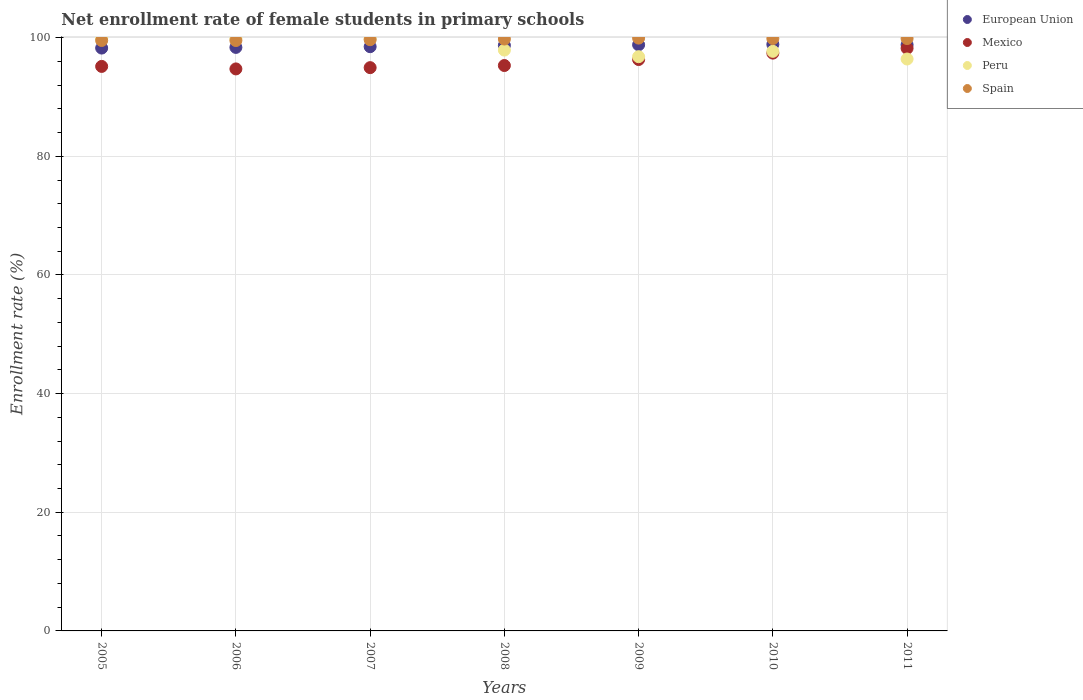What is the net enrollment rate of female students in primary schools in Mexico in 2008?
Provide a short and direct response. 95.3. Across all years, what is the maximum net enrollment rate of female students in primary schools in Mexico?
Ensure brevity in your answer.  98.2. Across all years, what is the minimum net enrollment rate of female students in primary schools in Mexico?
Give a very brief answer. 94.72. In which year was the net enrollment rate of female students in primary schools in Peru maximum?
Provide a short and direct response. 2005. In which year was the net enrollment rate of female students in primary schools in Mexico minimum?
Your answer should be very brief. 2006. What is the total net enrollment rate of female students in primary schools in European Union in the graph?
Offer a very short reply. 690.18. What is the difference between the net enrollment rate of female students in primary schools in Spain in 2008 and that in 2009?
Provide a succinct answer. -0.16. What is the difference between the net enrollment rate of female students in primary schools in Mexico in 2011 and the net enrollment rate of female students in primary schools in Spain in 2010?
Ensure brevity in your answer.  -1.64. What is the average net enrollment rate of female students in primary schools in Peru per year?
Your answer should be compact. 98.33. In the year 2006, what is the difference between the net enrollment rate of female students in primary schools in Spain and net enrollment rate of female students in primary schools in Peru?
Make the answer very short. -0.32. What is the ratio of the net enrollment rate of female students in primary schools in Spain in 2009 to that in 2011?
Keep it short and to the point. 1. Is the difference between the net enrollment rate of female students in primary schools in Spain in 2005 and 2008 greater than the difference between the net enrollment rate of female students in primary schools in Peru in 2005 and 2008?
Your response must be concise. No. What is the difference between the highest and the second highest net enrollment rate of female students in primary schools in Mexico?
Your answer should be very brief. 0.82. What is the difference between the highest and the lowest net enrollment rate of female students in primary schools in Spain?
Ensure brevity in your answer.  0.41. Is the sum of the net enrollment rate of female students in primary schools in European Union in 2008 and 2010 greater than the maximum net enrollment rate of female students in primary schools in Mexico across all years?
Ensure brevity in your answer.  Yes. Is it the case that in every year, the sum of the net enrollment rate of female students in primary schools in Spain and net enrollment rate of female students in primary schools in Mexico  is greater than the sum of net enrollment rate of female students in primary schools in Peru and net enrollment rate of female students in primary schools in European Union?
Ensure brevity in your answer.  No. Is it the case that in every year, the sum of the net enrollment rate of female students in primary schools in Spain and net enrollment rate of female students in primary schools in Mexico  is greater than the net enrollment rate of female students in primary schools in European Union?
Ensure brevity in your answer.  Yes. Does the net enrollment rate of female students in primary schools in Spain monotonically increase over the years?
Your answer should be very brief. No. Is the net enrollment rate of female students in primary schools in Spain strictly greater than the net enrollment rate of female students in primary schools in Peru over the years?
Give a very brief answer. No. How many dotlines are there?
Your response must be concise. 4. What is the difference between two consecutive major ticks on the Y-axis?
Offer a very short reply. 20. Does the graph contain any zero values?
Keep it short and to the point. No. Where does the legend appear in the graph?
Your answer should be compact. Top right. How many legend labels are there?
Your response must be concise. 4. How are the legend labels stacked?
Ensure brevity in your answer.  Vertical. What is the title of the graph?
Provide a succinct answer. Net enrollment rate of female students in primary schools. What is the label or title of the Y-axis?
Make the answer very short. Enrollment rate (%). What is the Enrollment rate (%) of European Union in 2005?
Ensure brevity in your answer.  98.24. What is the Enrollment rate (%) of Mexico in 2005?
Your response must be concise. 95.14. What is the Enrollment rate (%) of Peru in 2005?
Provide a succinct answer. 99.87. What is the Enrollment rate (%) of Spain in 2005?
Give a very brief answer. 99.52. What is the Enrollment rate (%) in European Union in 2006?
Provide a succinct answer. 98.35. What is the Enrollment rate (%) in Mexico in 2006?
Your answer should be compact. 94.72. What is the Enrollment rate (%) in Peru in 2006?
Give a very brief answer. 99.83. What is the Enrollment rate (%) in Spain in 2006?
Provide a succinct answer. 99.51. What is the Enrollment rate (%) in European Union in 2007?
Your answer should be very brief. 98.47. What is the Enrollment rate (%) in Mexico in 2007?
Offer a terse response. 94.94. What is the Enrollment rate (%) of Peru in 2007?
Your answer should be compact. 99.84. What is the Enrollment rate (%) in Spain in 2007?
Your answer should be very brief. 99.65. What is the Enrollment rate (%) in European Union in 2008?
Offer a terse response. 98.69. What is the Enrollment rate (%) in Mexico in 2008?
Your answer should be compact. 95.3. What is the Enrollment rate (%) of Peru in 2008?
Your answer should be very brief. 97.9. What is the Enrollment rate (%) of Spain in 2008?
Your answer should be compact. 99.76. What is the Enrollment rate (%) in European Union in 2009?
Your answer should be compact. 98.79. What is the Enrollment rate (%) of Mexico in 2009?
Provide a short and direct response. 96.31. What is the Enrollment rate (%) in Peru in 2009?
Your answer should be compact. 96.78. What is the Enrollment rate (%) in Spain in 2009?
Keep it short and to the point. 99.91. What is the Enrollment rate (%) in European Union in 2010?
Provide a short and direct response. 98.86. What is the Enrollment rate (%) of Mexico in 2010?
Keep it short and to the point. 97.39. What is the Enrollment rate (%) in Peru in 2010?
Offer a very short reply. 97.69. What is the Enrollment rate (%) in Spain in 2010?
Give a very brief answer. 99.84. What is the Enrollment rate (%) of European Union in 2011?
Offer a terse response. 98.79. What is the Enrollment rate (%) in Mexico in 2011?
Give a very brief answer. 98.2. What is the Enrollment rate (%) of Peru in 2011?
Your answer should be very brief. 96.39. What is the Enrollment rate (%) of Spain in 2011?
Provide a succinct answer. 99.84. Across all years, what is the maximum Enrollment rate (%) of European Union?
Give a very brief answer. 98.86. Across all years, what is the maximum Enrollment rate (%) of Mexico?
Provide a short and direct response. 98.2. Across all years, what is the maximum Enrollment rate (%) of Peru?
Your answer should be compact. 99.87. Across all years, what is the maximum Enrollment rate (%) in Spain?
Keep it short and to the point. 99.91. Across all years, what is the minimum Enrollment rate (%) of European Union?
Your response must be concise. 98.24. Across all years, what is the minimum Enrollment rate (%) in Mexico?
Give a very brief answer. 94.72. Across all years, what is the minimum Enrollment rate (%) of Peru?
Provide a succinct answer. 96.39. Across all years, what is the minimum Enrollment rate (%) in Spain?
Keep it short and to the point. 99.51. What is the total Enrollment rate (%) of European Union in the graph?
Offer a terse response. 690.18. What is the total Enrollment rate (%) of Mexico in the graph?
Provide a short and direct response. 672. What is the total Enrollment rate (%) in Peru in the graph?
Provide a short and direct response. 688.3. What is the total Enrollment rate (%) in Spain in the graph?
Your answer should be very brief. 698.03. What is the difference between the Enrollment rate (%) in European Union in 2005 and that in 2006?
Your answer should be very brief. -0.11. What is the difference between the Enrollment rate (%) in Mexico in 2005 and that in 2006?
Offer a terse response. 0.42. What is the difference between the Enrollment rate (%) of Peru in 2005 and that in 2006?
Make the answer very short. 0.04. What is the difference between the Enrollment rate (%) in Spain in 2005 and that in 2006?
Provide a short and direct response. 0.01. What is the difference between the Enrollment rate (%) in European Union in 2005 and that in 2007?
Keep it short and to the point. -0.23. What is the difference between the Enrollment rate (%) in Mexico in 2005 and that in 2007?
Provide a short and direct response. 0.21. What is the difference between the Enrollment rate (%) of Peru in 2005 and that in 2007?
Provide a succinct answer. 0.03. What is the difference between the Enrollment rate (%) of Spain in 2005 and that in 2007?
Your answer should be compact. -0.13. What is the difference between the Enrollment rate (%) of European Union in 2005 and that in 2008?
Provide a succinct answer. -0.46. What is the difference between the Enrollment rate (%) of Mexico in 2005 and that in 2008?
Provide a short and direct response. -0.15. What is the difference between the Enrollment rate (%) of Peru in 2005 and that in 2008?
Offer a very short reply. 1.97. What is the difference between the Enrollment rate (%) of Spain in 2005 and that in 2008?
Ensure brevity in your answer.  -0.24. What is the difference between the Enrollment rate (%) in European Union in 2005 and that in 2009?
Give a very brief answer. -0.55. What is the difference between the Enrollment rate (%) in Mexico in 2005 and that in 2009?
Keep it short and to the point. -1.16. What is the difference between the Enrollment rate (%) in Peru in 2005 and that in 2009?
Provide a short and direct response. 3.09. What is the difference between the Enrollment rate (%) in Spain in 2005 and that in 2009?
Keep it short and to the point. -0.4. What is the difference between the Enrollment rate (%) in European Union in 2005 and that in 2010?
Your answer should be very brief. -0.62. What is the difference between the Enrollment rate (%) of Mexico in 2005 and that in 2010?
Ensure brevity in your answer.  -2.24. What is the difference between the Enrollment rate (%) in Peru in 2005 and that in 2010?
Make the answer very short. 2.18. What is the difference between the Enrollment rate (%) of Spain in 2005 and that in 2010?
Provide a short and direct response. -0.32. What is the difference between the Enrollment rate (%) in European Union in 2005 and that in 2011?
Ensure brevity in your answer.  -0.55. What is the difference between the Enrollment rate (%) in Mexico in 2005 and that in 2011?
Give a very brief answer. -3.06. What is the difference between the Enrollment rate (%) of Peru in 2005 and that in 2011?
Ensure brevity in your answer.  3.48. What is the difference between the Enrollment rate (%) in Spain in 2005 and that in 2011?
Provide a succinct answer. -0.33. What is the difference between the Enrollment rate (%) of European Union in 2006 and that in 2007?
Give a very brief answer. -0.12. What is the difference between the Enrollment rate (%) of Mexico in 2006 and that in 2007?
Provide a short and direct response. -0.21. What is the difference between the Enrollment rate (%) of Peru in 2006 and that in 2007?
Make the answer very short. -0.01. What is the difference between the Enrollment rate (%) of Spain in 2006 and that in 2007?
Keep it short and to the point. -0.14. What is the difference between the Enrollment rate (%) in European Union in 2006 and that in 2008?
Offer a terse response. -0.35. What is the difference between the Enrollment rate (%) of Mexico in 2006 and that in 2008?
Offer a terse response. -0.57. What is the difference between the Enrollment rate (%) of Peru in 2006 and that in 2008?
Your answer should be compact. 1.93. What is the difference between the Enrollment rate (%) of Spain in 2006 and that in 2008?
Your answer should be compact. -0.25. What is the difference between the Enrollment rate (%) in European Union in 2006 and that in 2009?
Provide a short and direct response. -0.44. What is the difference between the Enrollment rate (%) in Mexico in 2006 and that in 2009?
Your answer should be very brief. -1.58. What is the difference between the Enrollment rate (%) of Peru in 2006 and that in 2009?
Keep it short and to the point. 3.05. What is the difference between the Enrollment rate (%) of Spain in 2006 and that in 2009?
Provide a succinct answer. -0.41. What is the difference between the Enrollment rate (%) of European Union in 2006 and that in 2010?
Give a very brief answer. -0.51. What is the difference between the Enrollment rate (%) of Mexico in 2006 and that in 2010?
Your answer should be compact. -2.66. What is the difference between the Enrollment rate (%) of Peru in 2006 and that in 2010?
Offer a terse response. 2.14. What is the difference between the Enrollment rate (%) of Spain in 2006 and that in 2010?
Offer a terse response. -0.33. What is the difference between the Enrollment rate (%) of European Union in 2006 and that in 2011?
Offer a terse response. -0.44. What is the difference between the Enrollment rate (%) of Mexico in 2006 and that in 2011?
Your response must be concise. -3.48. What is the difference between the Enrollment rate (%) of Peru in 2006 and that in 2011?
Your response must be concise. 3.44. What is the difference between the Enrollment rate (%) in Spain in 2006 and that in 2011?
Make the answer very short. -0.34. What is the difference between the Enrollment rate (%) of European Union in 2007 and that in 2008?
Your answer should be very brief. -0.22. What is the difference between the Enrollment rate (%) of Mexico in 2007 and that in 2008?
Provide a succinct answer. -0.36. What is the difference between the Enrollment rate (%) of Peru in 2007 and that in 2008?
Ensure brevity in your answer.  1.95. What is the difference between the Enrollment rate (%) in Spain in 2007 and that in 2008?
Give a very brief answer. -0.11. What is the difference between the Enrollment rate (%) in European Union in 2007 and that in 2009?
Provide a short and direct response. -0.32. What is the difference between the Enrollment rate (%) in Mexico in 2007 and that in 2009?
Your answer should be compact. -1.37. What is the difference between the Enrollment rate (%) in Peru in 2007 and that in 2009?
Your response must be concise. 3.06. What is the difference between the Enrollment rate (%) of Spain in 2007 and that in 2009?
Offer a very short reply. -0.27. What is the difference between the Enrollment rate (%) of European Union in 2007 and that in 2010?
Give a very brief answer. -0.39. What is the difference between the Enrollment rate (%) of Mexico in 2007 and that in 2010?
Make the answer very short. -2.45. What is the difference between the Enrollment rate (%) of Peru in 2007 and that in 2010?
Your answer should be compact. 2.16. What is the difference between the Enrollment rate (%) in Spain in 2007 and that in 2010?
Provide a succinct answer. -0.19. What is the difference between the Enrollment rate (%) of European Union in 2007 and that in 2011?
Provide a succinct answer. -0.32. What is the difference between the Enrollment rate (%) of Mexico in 2007 and that in 2011?
Make the answer very short. -3.26. What is the difference between the Enrollment rate (%) in Peru in 2007 and that in 2011?
Offer a very short reply. 3.45. What is the difference between the Enrollment rate (%) in Spain in 2007 and that in 2011?
Your answer should be compact. -0.2. What is the difference between the Enrollment rate (%) of European Union in 2008 and that in 2009?
Give a very brief answer. -0.09. What is the difference between the Enrollment rate (%) of Mexico in 2008 and that in 2009?
Your answer should be very brief. -1.01. What is the difference between the Enrollment rate (%) in Peru in 2008 and that in 2009?
Offer a very short reply. 1.11. What is the difference between the Enrollment rate (%) in Spain in 2008 and that in 2009?
Keep it short and to the point. -0.16. What is the difference between the Enrollment rate (%) of European Union in 2008 and that in 2010?
Ensure brevity in your answer.  -0.16. What is the difference between the Enrollment rate (%) of Mexico in 2008 and that in 2010?
Provide a short and direct response. -2.09. What is the difference between the Enrollment rate (%) of Peru in 2008 and that in 2010?
Provide a succinct answer. 0.21. What is the difference between the Enrollment rate (%) in Spain in 2008 and that in 2010?
Offer a terse response. -0.08. What is the difference between the Enrollment rate (%) of European Union in 2008 and that in 2011?
Offer a terse response. -0.09. What is the difference between the Enrollment rate (%) in Mexico in 2008 and that in 2011?
Ensure brevity in your answer.  -2.91. What is the difference between the Enrollment rate (%) in Peru in 2008 and that in 2011?
Offer a very short reply. 1.5. What is the difference between the Enrollment rate (%) of Spain in 2008 and that in 2011?
Your answer should be compact. -0.09. What is the difference between the Enrollment rate (%) of European Union in 2009 and that in 2010?
Your answer should be compact. -0.07. What is the difference between the Enrollment rate (%) in Mexico in 2009 and that in 2010?
Give a very brief answer. -1.08. What is the difference between the Enrollment rate (%) of Peru in 2009 and that in 2010?
Provide a short and direct response. -0.9. What is the difference between the Enrollment rate (%) of Spain in 2009 and that in 2010?
Provide a short and direct response. 0.07. What is the difference between the Enrollment rate (%) in European Union in 2009 and that in 2011?
Provide a short and direct response. 0. What is the difference between the Enrollment rate (%) of Mexico in 2009 and that in 2011?
Offer a very short reply. -1.9. What is the difference between the Enrollment rate (%) in Peru in 2009 and that in 2011?
Offer a terse response. 0.39. What is the difference between the Enrollment rate (%) in Spain in 2009 and that in 2011?
Keep it short and to the point. 0.07. What is the difference between the Enrollment rate (%) of European Union in 2010 and that in 2011?
Your answer should be very brief. 0.07. What is the difference between the Enrollment rate (%) of Mexico in 2010 and that in 2011?
Offer a very short reply. -0.82. What is the difference between the Enrollment rate (%) of Peru in 2010 and that in 2011?
Give a very brief answer. 1.29. What is the difference between the Enrollment rate (%) in Spain in 2010 and that in 2011?
Keep it short and to the point. -0. What is the difference between the Enrollment rate (%) in European Union in 2005 and the Enrollment rate (%) in Mexico in 2006?
Your answer should be very brief. 3.51. What is the difference between the Enrollment rate (%) of European Union in 2005 and the Enrollment rate (%) of Peru in 2006?
Offer a very short reply. -1.59. What is the difference between the Enrollment rate (%) in European Union in 2005 and the Enrollment rate (%) in Spain in 2006?
Give a very brief answer. -1.27. What is the difference between the Enrollment rate (%) of Mexico in 2005 and the Enrollment rate (%) of Peru in 2006?
Offer a very short reply. -4.69. What is the difference between the Enrollment rate (%) of Mexico in 2005 and the Enrollment rate (%) of Spain in 2006?
Give a very brief answer. -4.36. What is the difference between the Enrollment rate (%) in Peru in 2005 and the Enrollment rate (%) in Spain in 2006?
Keep it short and to the point. 0.36. What is the difference between the Enrollment rate (%) of European Union in 2005 and the Enrollment rate (%) of Mexico in 2007?
Your answer should be compact. 3.3. What is the difference between the Enrollment rate (%) in European Union in 2005 and the Enrollment rate (%) in Peru in 2007?
Offer a terse response. -1.61. What is the difference between the Enrollment rate (%) in European Union in 2005 and the Enrollment rate (%) in Spain in 2007?
Provide a short and direct response. -1.41. What is the difference between the Enrollment rate (%) in Mexico in 2005 and the Enrollment rate (%) in Peru in 2007?
Your answer should be very brief. -4.7. What is the difference between the Enrollment rate (%) in Mexico in 2005 and the Enrollment rate (%) in Spain in 2007?
Give a very brief answer. -4.5. What is the difference between the Enrollment rate (%) of Peru in 2005 and the Enrollment rate (%) of Spain in 2007?
Keep it short and to the point. 0.22. What is the difference between the Enrollment rate (%) of European Union in 2005 and the Enrollment rate (%) of Mexico in 2008?
Provide a short and direct response. 2.94. What is the difference between the Enrollment rate (%) in European Union in 2005 and the Enrollment rate (%) in Peru in 2008?
Ensure brevity in your answer.  0.34. What is the difference between the Enrollment rate (%) of European Union in 2005 and the Enrollment rate (%) of Spain in 2008?
Keep it short and to the point. -1.52. What is the difference between the Enrollment rate (%) in Mexico in 2005 and the Enrollment rate (%) in Peru in 2008?
Keep it short and to the point. -2.75. What is the difference between the Enrollment rate (%) in Mexico in 2005 and the Enrollment rate (%) in Spain in 2008?
Ensure brevity in your answer.  -4.61. What is the difference between the Enrollment rate (%) in Peru in 2005 and the Enrollment rate (%) in Spain in 2008?
Give a very brief answer. 0.11. What is the difference between the Enrollment rate (%) in European Union in 2005 and the Enrollment rate (%) in Mexico in 2009?
Give a very brief answer. 1.93. What is the difference between the Enrollment rate (%) in European Union in 2005 and the Enrollment rate (%) in Peru in 2009?
Make the answer very short. 1.45. What is the difference between the Enrollment rate (%) of European Union in 2005 and the Enrollment rate (%) of Spain in 2009?
Offer a very short reply. -1.68. What is the difference between the Enrollment rate (%) of Mexico in 2005 and the Enrollment rate (%) of Peru in 2009?
Your answer should be compact. -1.64. What is the difference between the Enrollment rate (%) of Mexico in 2005 and the Enrollment rate (%) of Spain in 2009?
Make the answer very short. -4.77. What is the difference between the Enrollment rate (%) of Peru in 2005 and the Enrollment rate (%) of Spain in 2009?
Your answer should be compact. -0.05. What is the difference between the Enrollment rate (%) in European Union in 2005 and the Enrollment rate (%) in Mexico in 2010?
Keep it short and to the point. 0.85. What is the difference between the Enrollment rate (%) of European Union in 2005 and the Enrollment rate (%) of Peru in 2010?
Your answer should be compact. 0.55. What is the difference between the Enrollment rate (%) in European Union in 2005 and the Enrollment rate (%) in Spain in 2010?
Your response must be concise. -1.6. What is the difference between the Enrollment rate (%) in Mexico in 2005 and the Enrollment rate (%) in Peru in 2010?
Your response must be concise. -2.54. What is the difference between the Enrollment rate (%) of Mexico in 2005 and the Enrollment rate (%) of Spain in 2010?
Your answer should be compact. -4.7. What is the difference between the Enrollment rate (%) of Peru in 2005 and the Enrollment rate (%) of Spain in 2010?
Your answer should be very brief. 0.03. What is the difference between the Enrollment rate (%) of European Union in 2005 and the Enrollment rate (%) of Mexico in 2011?
Keep it short and to the point. 0.03. What is the difference between the Enrollment rate (%) in European Union in 2005 and the Enrollment rate (%) in Peru in 2011?
Offer a very short reply. 1.84. What is the difference between the Enrollment rate (%) of European Union in 2005 and the Enrollment rate (%) of Spain in 2011?
Make the answer very short. -1.61. What is the difference between the Enrollment rate (%) of Mexico in 2005 and the Enrollment rate (%) of Peru in 2011?
Ensure brevity in your answer.  -1.25. What is the difference between the Enrollment rate (%) in Mexico in 2005 and the Enrollment rate (%) in Spain in 2011?
Ensure brevity in your answer.  -4.7. What is the difference between the Enrollment rate (%) in Peru in 2005 and the Enrollment rate (%) in Spain in 2011?
Provide a short and direct response. 0.03. What is the difference between the Enrollment rate (%) in European Union in 2006 and the Enrollment rate (%) in Mexico in 2007?
Your response must be concise. 3.41. What is the difference between the Enrollment rate (%) of European Union in 2006 and the Enrollment rate (%) of Peru in 2007?
Provide a succinct answer. -1.5. What is the difference between the Enrollment rate (%) in European Union in 2006 and the Enrollment rate (%) in Spain in 2007?
Offer a very short reply. -1.3. What is the difference between the Enrollment rate (%) of Mexico in 2006 and the Enrollment rate (%) of Peru in 2007?
Give a very brief answer. -5.12. What is the difference between the Enrollment rate (%) in Mexico in 2006 and the Enrollment rate (%) in Spain in 2007?
Offer a terse response. -4.92. What is the difference between the Enrollment rate (%) in Peru in 2006 and the Enrollment rate (%) in Spain in 2007?
Provide a succinct answer. 0.18. What is the difference between the Enrollment rate (%) in European Union in 2006 and the Enrollment rate (%) in Mexico in 2008?
Offer a very short reply. 3.05. What is the difference between the Enrollment rate (%) in European Union in 2006 and the Enrollment rate (%) in Peru in 2008?
Keep it short and to the point. 0.45. What is the difference between the Enrollment rate (%) of European Union in 2006 and the Enrollment rate (%) of Spain in 2008?
Offer a very short reply. -1.41. What is the difference between the Enrollment rate (%) in Mexico in 2006 and the Enrollment rate (%) in Peru in 2008?
Make the answer very short. -3.17. What is the difference between the Enrollment rate (%) in Mexico in 2006 and the Enrollment rate (%) in Spain in 2008?
Give a very brief answer. -5.03. What is the difference between the Enrollment rate (%) of Peru in 2006 and the Enrollment rate (%) of Spain in 2008?
Offer a terse response. 0.07. What is the difference between the Enrollment rate (%) in European Union in 2006 and the Enrollment rate (%) in Mexico in 2009?
Your answer should be very brief. 2.04. What is the difference between the Enrollment rate (%) of European Union in 2006 and the Enrollment rate (%) of Peru in 2009?
Make the answer very short. 1.57. What is the difference between the Enrollment rate (%) of European Union in 2006 and the Enrollment rate (%) of Spain in 2009?
Provide a short and direct response. -1.57. What is the difference between the Enrollment rate (%) of Mexico in 2006 and the Enrollment rate (%) of Peru in 2009?
Your answer should be very brief. -2.06. What is the difference between the Enrollment rate (%) in Mexico in 2006 and the Enrollment rate (%) in Spain in 2009?
Your answer should be compact. -5.19. What is the difference between the Enrollment rate (%) in Peru in 2006 and the Enrollment rate (%) in Spain in 2009?
Your answer should be compact. -0.08. What is the difference between the Enrollment rate (%) of European Union in 2006 and the Enrollment rate (%) of Mexico in 2010?
Your answer should be very brief. 0.96. What is the difference between the Enrollment rate (%) in European Union in 2006 and the Enrollment rate (%) in Peru in 2010?
Offer a terse response. 0.66. What is the difference between the Enrollment rate (%) in European Union in 2006 and the Enrollment rate (%) in Spain in 2010?
Your answer should be very brief. -1.49. What is the difference between the Enrollment rate (%) in Mexico in 2006 and the Enrollment rate (%) in Peru in 2010?
Make the answer very short. -2.96. What is the difference between the Enrollment rate (%) of Mexico in 2006 and the Enrollment rate (%) of Spain in 2010?
Your response must be concise. -5.12. What is the difference between the Enrollment rate (%) of Peru in 2006 and the Enrollment rate (%) of Spain in 2010?
Your answer should be compact. -0.01. What is the difference between the Enrollment rate (%) of European Union in 2006 and the Enrollment rate (%) of Mexico in 2011?
Ensure brevity in your answer.  0.15. What is the difference between the Enrollment rate (%) in European Union in 2006 and the Enrollment rate (%) in Peru in 2011?
Provide a succinct answer. 1.96. What is the difference between the Enrollment rate (%) in European Union in 2006 and the Enrollment rate (%) in Spain in 2011?
Offer a terse response. -1.49. What is the difference between the Enrollment rate (%) of Mexico in 2006 and the Enrollment rate (%) of Peru in 2011?
Offer a very short reply. -1.67. What is the difference between the Enrollment rate (%) in Mexico in 2006 and the Enrollment rate (%) in Spain in 2011?
Offer a terse response. -5.12. What is the difference between the Enrollment rate (%) of Peru in 2006 and the Enrollment rate (%) of Spain in 2011?
Offer a terse response. -0.01. What is the difference between the Enrollment rate (%) in European Union in 2007 and the Enrollment rate (%) in Mexico in 2008?
Your answer should be very brief. 3.18. What is the difference between the Enrollment rate (%) of European Union in 2007 and the Enrollment rate (%) of Peru in 2008?
Make the answer very short. 0.57. What is the difference between the Enrollment rate (%) of European Union in 2007 and the Enrollment rate (%) of Spain in 2008?
Give a very brief answer. -1.29. What is the difference between the Enrollment rate (%) in Mexico in 2007 and the Enrollment rate (%) in Peru in 2008?
Your response must be concise. -2.96. What is the difference between the Enrollment rate (%) of Mexico in 2007 and the Enrollment rate (%) of Spain in 2008?
Your answer should be very brief. -4.82. What is the difference between the Enrollment rate (%) of Peru in 2007 and the Enrollment rate (%) of Spain in 2008?
Provide a succinct answer. 0.09. What is the difference between the Enrollment rate (%) of European Union in 2007 and the Enrollment rate (%) of Mexico in 2009?
Make the answer very short. 2.16. What is the difference between the Enrollment rate (%) of European Union in 2007 and the Enrollment rate (%) of Peru in 2009?
Provide a short and direct response. 1.69. What is the difference between the Enrollment rate (%) of European Union in 2007 and the Enrollment rate (%) of Spain in 2009?
Make the answer very short. -1.44. What is the difference between the Enrollment rate (%) in Mexico in 2007 and the Enrollment rate (%) in Peru in 2009?
Give a very brief answer. -1.84. What is the difference between the Enrollment rate (%) in Mexico in 2007 and the Enrollment rate (%) in Spain in 2009?
Offer a terse response. -4.98. What is the difference between the Enrollment rate (%) of Peru in 2007 and the Enrollment rate (%) of Spain in 2009?
Provide a short and direct response. -0.07. What is the difference between the Enrollment rate (%) of European Union in 2007 and the Enrollment rate (%) of Mexico in 2010?
Your answer should be very brief. 1.09. What is the difference between the Enrollment rate (%) of European Union in 2007 and the Enrollment rate (%) of Peru in 2010?
Ensure brevity in your answer.  0.78. What is the difference between the Enrollment rate (%) in European Union in 2007 and the Enrollment rate (%) in Spain in 2010?
Offer a terse response. -1.37. What is the difference between the Enrollment rate (%) in Mexico in 2007 and the Enrollment rate (%) in Peru in 2010?
Offer a terse response. -2.75. What is the difference between the Enrollment rate (%) of Mexico in 2007 and the Enrollment rate (%) of Spain in 2010?
Give a very brief answer. -4.9. What is the difference between the Enrollment rate (%) of Peru in 2007 and the Enrollment rate (%) of Spain in 2010?
Your answer should be compact. 0. What is the difference between the Enrollment rate (%) in European Union in 2007 and the Enrollment rate (%) in Mexico in 2011?
Give a very brief answer. 0.27. What is the difference between the Enrollment rate (%) of European Union in 2007 and the Enrollment rate (%) of Peru in 2011?
Give a very brief answer. 2.08. What is the difference between the Enrollment rate (%) of European Union in 2007 and the Enrollment rate (%) of Spain in 2011?
Provide a succinct answer. -1.37. What is the difference between the Enrollment rate (%) of Mexico in 2007 and the Enrollment rate (%) of Peru in 2011?
Give a very brief answer. -1.45. What is the difference between the Enrollment rate (%) of Mexico in 2007 and the Enrollment rate (%) of Spain in 2011?
Give a very brief answer. -4.91. What is the difference between the Enrollment rate (%) of Peru in 2007 and the Enrollment rate (%) of Spain in 2011?
Give a very brief answer. 0. What is the difference between the Enrollment rate (%) in European Union in 2008 and the Enrollment rate (%) in Mexico in 2009?
Provide a short and direct response. 2.39. What is the difference between the Enrollment rate (%) of European Union in 2008 and the Enrollment rate (%) of Peru in 2009?
Make the answer very short. 1.91. What is the difference between the Enrollment rate (%) in European Union in 2008 and the Enrollment rate (%) in Spain in 2009?
Keep it short and to the point. -1.22. What is the difference between the Enrollment rate (%) in Mexico in 2008 and the Enrollment rate (%) in Peru in 2009?
Keep it short and to the point. -1.49. What is the difference between the Enrollment rate (%) of Mexico in 2008 and the Enrollment rate (%) of Spain in 2009?
Give a very brief answer. -4.62. What is the difference between the Enrollment rate (%) in Peru in 2008 and the Enrollment rate (%) in Spain in 2009?
Keep it short and to the point. -2.02. What is the difference between the Enrollment rate (%) of European Union in 2008 and the Enrollment rate (%) of Mexico in 2010?
Your response must be concise. 1.31. What is the difference between the Enrollment rate (%) in European Union in 2008 and the Enrollment rate (%) in Peru in 2010?
Ensure brevity in your answer.  1.01. What is the difference between the Enrollment rate (%) in European Union in 2008 and the Enrollment rate (%) in Spain in 2010?
Provide a succinct answer. -1.15. What is the difference between the Enrollment rate (%) of Mexico in 2008 and the Enrollment rate (%) of Peru in 2010?
Make the answer very short. -2.39. What is the difference between the Enrollment rate (%) in Mexico in 2008 and the Enrollment rate (%) in Spain in 2010?
Ensure brevity in your answer.  -4.54. What is the difference between the Enrollment rate (%) of Peru in 2008 and the Enrollment rate (%) of Spain in 2010?
Your answer should be compact. -1.94. What is the difference between the Enrollment rate (%) in European Union in 2008 and the Enrollment rate (%) in Mexico in 2011?
Offer a very short reply. 0.49. What is the difference between the Enrollment rate (%) in European Union in 2008 and the Enrollment rate (%) in Peru in 2011?
Make the answer very short. 2.3. What is the difference between the Enrollment rate (%) in European Union in 2008 and the Enrollment rate (%) in Spain in 2011?
Offer a very short reply. -1.15. What is the difference between the Enrollment rate (%) in Mexico in 2008 and the Enrollment rate (%) in Peru in 2011?
Your response must be concise. -1.1. What is the difference between the Enrollment rate (%) of Mexico in 2008 and the Enrollment rate (%) of Spain in 2011?
Keep it short and to the point. -4.55. What is the difference between the Enrollment rate (%) of Peru in 2008 and the Enrollment rate (%) of Spain in 2011?
Your response must be concise. -1.95. What is the difference between the Enrollment rate (%) in European Union in 2009 and the Enrollment rate (%) in Mexico in 2010?
Give a very brief answer. 1.4. What is the difference between the Enrollment rate (%) in European Union in 2009 and the Enrollment rate (%) in Peru in 2010?
Your response must be concise. 1.1. What is the difference between the Enrollment rate (%) in European Union in 2009 and the Enrollment rate (%) in Spain in 2010?
Offer a very short reply. -1.05. What is the difference between the Enrollment rate (%) in Mexico in 2009 and the Enrollment rate (%) in Peru in 2010?
Provide a succinct answer. -1.38. What is the difference between the Enrollment rate (%) in Mexico in 2009 and the Enrollment rate (%) in Spain in 2010?
Provide a short and direct response. -3.53. What is the difference between the Enrollment rate (%) of Peru in 2009 and the Enrollment rate (%) of Spain in 2010?
Offer a terse response. -3.06. What is the difference between the Enrollment rate (%) in European Union in 2009 and the Enrollment rate (%) in Mexico in 2011?
Provide a short and direct response. 0.58. What is the difference between the Enrollment rate (%) in European Union in 2009 and the Enrollment rate (%) in Peru in 2011?
Your response must be concise. 2.39. What is the difference between the Enrollment rate (%) in European Union in 2009 and the Enrollment rate (%) in Spain in 2011?
Ensure brevity in your answer.  -1.06. What is the difference between the Enrollment rate (%) of Mexico in 2009 and the Enrollment rate (%) of Peru in 2011?
Make the answer very short. -0.09. What is the difference between the Enrollment rate (%) of Mexico in 2009 and the Enrollment rate (%) of Spain in 2011?
Provide a succinct answer. -3.54. What is the difference between the Enrollment rate (%) in Peru in 2009 and the Enrollment rate (%) in Spain in 2011?
Provide a short and direct response. -3.06. What is the difference between the Enrollment rate (%) of European Union in 2010 and the Enrollment rate (%) of Mexico in 2011?
Your response must be concise. 0.65. What is the difference between the Enrollment rate (%) in European Union in 2010 and the Enrollment rate (%) in Peru in 2011?
Give a very brief answer. 2.46. What is the difference between the Enrollment rate (%) in European Union in 2010 and the Enrollment rate (%) in Spain in 2011?
Provide a succinct answer. -0.99. What is the difference between the Enrollment rate (%) in Mexico in 2010 and the Enrollment rate (%) in Peru in 2011?
Your answer should be very brief. 0.99. What is the difference between the Enrollment rate (%) of Mexico in 2010 and the Enrollment rate (%) of Spain in 2011?
Provide a succinct answer. -2.46. What is the difference between the Enrollment rate (%) in Peru in 2010 and the Enrollment rate (%) in Spain in 2011?
Offer a terse response. -2.16. What is the average Enrollment rate (%) of European Union per year?
Provide a succinct answer. 98.6. What is the average Enrollment rate (%) of Mexico per year?
Offer a very short reply. 96. What is the average Enrollment rate (%) in Peru per year?
Provide a short and direct response. 98.33. What is the average Enrollment rate (%) of Spain per year?
Provide a succinct answer. 99.72. In the year 2005, what is the difference between the Enrollment rate (%) of European Union and Enrollment rate (%) of Mexico?
Offer a terse response. 3.09. In the year 2005, what is the difference between the Enrollment rate (%) of European Union and Enrollment rate (%) of Peru?
Keep it short and to the point. -1.63. In the year 2005, what is the difference between the Enrollment rate (%) in European Union and Enrollment rate (%) in Spain?
Offer a very short reply. -1.28. In the year 2005, what is the difference between the Enrollment rate (%) in Mexico and Enrollment rate (%) in Peru?
Offer a terse response. -4.73. In the year 2005, what is the difference between the Enrollment rate (%) of Mexico and Enrollment rate (%) of Spain?
Provide a succinct answer. -4.37. In the year 2005, what is the difference between the Enrollment rate (%) of Peru and Enrollment rate (%) of Spain?
Your answer should be compact. 0.35. In the year 2006, what is the difference between the Enrollment rate (%) in European Union and Enrollment rate (%) in Mexico?
Ensure brevity in your answer.  3.63. In the year 2006, what is the difference between the Enrollment rate (%) in European Union and Enrollment rate (%) in Peru?
Give a very brief answer. -1.48. In the year 2006, what is the difference between the Enrollment rate (%) in European Union and Enrollment rate (%) in Spain?
Your response must be concise. -1.16. In the year 2006, what is the difference between the Enrollment rate (%) of Mexico and Enrollment rate (%) of Peru?
Your response must be concise. -5.11. In the year 2006, what is the difference between the Enrollment rate (%) of Mexico and Enrollment rate (%) of Spain?
Offer a very short reply. -4.78. In the year 2006, what is the difference between the Enrollment rate (%) of Peru and Enrollment rate (%) of Spain?
Provide a short and direct response. 0.32. In the year 2007, what is the difference between the Enrollment rate (%) of European Union and Enrollment rate (%) of Mexico?
Your response must be concise. 3.53. In the year 2007, what is the difference between the Enrollment rate (%) in European Union and Enrollment rate (%) in Peru?
Your answer should be compact. -1.37. In the year 2007, what is the difference between the Enrollment rate (%) of European Union and Enrollment rate (%) of Spain?
Provide a succinct answer. -1.18. In the year 2007, what is the difference between the Enrollment rate (%) of Mexico and Enrollment rate (%) of Peru?
Provide a succinct answer. -4.91. In the year 2007, what is the difference between the Enrollment rate (%) of Mexico and Enrollment rate (%) of Spain?
Provide a short and direct response. -4.71. In the year 2007, what is the difference between the Enrollment rate (%) of Peru and Enrollment rate (%) of Spain?
Provide a short and direct response. 0.2. In the year 2008, what is the difference between the Enrollment rate (%) in European Union and Enrollment rate (%) in Mexico?
Offer a terse response. 3.4. In the year 2008, what is the difference between the Enrollment rate (%) in European Union and Enrollment rate (%) in Peru?
Give a very brief answer. 0.8. In the year 2008, what is the difference between the Enrollment rate (%) in European Union and Enrollment rate (%) in Spain?
Provide a succinct answer. -1.06. In the year 2008, what is the difference between the Enrollment rate (%) in Mexico and Enrollment rate (%) in Peru?
Give a very brief answer. -2.6. In the year 2008, what is the difference between the Enrollment rate (%) in Mexico and Enrollment rate (%) in Spain?
Ensure brevity in your answer.  -4.46. In the year 2008, what is the difference between the Enrollment rate (%) in Peru and Enrollment rate (%) in Spain?
Your answer should be very brief. -1.86. In the year 2009, what is the difference between the Enrollment rate (%) in European Union and Enrollment rate (%) in Mexico?
Your answer should be very brief. 2.48. In the year 2009, what is the difference between the Enrollment rate (%) in European Union and Enrollment rate (%) in Peru?
Make the answer very short. 2. In the year 2009, what is the difference between the Enrollment rate (%) of European Union and Enrollment rate (%) of Spain?
Give a very brief answer. -1.13. In the year 2009, what is the difference between the Enrollment rate (%) in Mexico and Enrollment rate (%) in Peru?
Your response must be concise. -0.48. In the year 2009, what is the difference between the Enrollment rate (%) of Mexico and Enrollment rate (%) of Spain?
Provide a short and direct response. -3.61. In the year 2009, what is the difference between the Enrollment rate (%) of Peru and Enrollment rate (%) of Spain?
Make the answer very short. -3.13. In the year 2010, what is the difference between the Enrollment rate (%) of European Union and Enrollment rate (%) of Mexico?
Keep it short and to the point. 1.47. In the year 2010, what is the difference between the Enrollment rate (%) in European Union and Enrollment rate (%) in Peru?
Provide a succinct answer. 1.17. In the year 2010, what is the difference between the Enrollment rate (%) of European Union and Enrollment rate (%) of Spain?
Your answer should be very brief. -0.98. In the year 2010, what is the difference between the Enrollment rate (%) in Mexico and Enrollment rate (%) in Peru?
Your answer should be compact. -0.3. In the year 2010, what is the difference between the Enrollment rate (%) in Mexico and Enrollment rate (%) in Spain?
Keep it short and to the point. -2.45. In the year 2010, what is the difference between the Enrollment rate (%) of Peru and Enrollment rate (%) of Spain?
Your answer should be compact. -2.15. In the year 2011, what is the difference between the Enrollment rate (%) in European Union and Enrollment rate (%) in Mexico?
Make the answer very short. 0.58. In the year 2011, what is the difference between the Enrollment rate (%) of European Union and Enrollment rate (%) of Peru?
Make the answer very short. 2.39. In the year 2011, what is the difference between the Enrollment rate (%) of European Union and Enrollment rate (%) of Spain?
Offer a very short reply. -1.06. In the year 2011, what is the difference between the Enrollment rate (%) in Mexico and Enrollment rate (%) in Peru?
Provide a short and direct response. 1.81. In the year 2011, what is the difference between the Enrollment rate (%) in Mexico and Enrollment rate (%) in Spain?
Offer a terse response. -1.64. In the year 2011, what is the difference between the Enrollment rate (%) of Peru and Enrollment rate (%) of Spain?
Provide a succinct answer. -3.45. What is the ratio of the Enrollment rate (%) of Mexico in 2005 to that in 2006?
Your answer should be compact. 1. What is the ratio of the Enrollment rate (%) of Peru in 2005 to that in 2006?
Make the answer very short. 1. What is the ratio of the Enrollment rate (%) in Spain in 2005 to that in 2006?
Your answer should be very brief. 1. What is the ratio of the Enrollment rate (%) in Mexico in 2005 to that in 2007?
Offer a terse response. 1. What is the ratio of the Enrollment rate (%) of European Union in 2005 to that in 2008?
Your answer should be very brief. 1. What is the ratio of the Enrollment rate (%) in Mexico in 2005 to that in 2008?
Give a very brief answer. 1. What is the ratio of the Enrollment rate (%) in Peru in 2005 to that in 2008?
Provide a succinct answer. 1.02. What is the ratio of the Enrollment rate (%) in Spain in 2005 to that in 2008?
Offer a terse response. 1. What is the ratio of the Enrollment rate (%) of European Union in 2005 to that in 2009?
Your answer should be very brief. 0.99. What is the ratio of the Enrollment rate (%) in Mexico in 2005 to that in 2009?
Your answer should be very brief. 0.99. What is the ratio of the Enrollment rate (%) in Peru in 2005 to that in 2009?
Your response must be concise. 1.03. What is the ratio of the Enrollment rate (%) in European Union in 2005 to that in 2010?
Your answer should be compact. 0.99. What is the ratio of the Enrollment rate (%) of Peru in 2005 to that in 2010?
Provide a succinct answer. 1.02. What is the ratio of the Enrollment rate (%) in Mexico in 2005 to that in 2011?
Provide a succinct answer. 0.97. What is the ratio of the Enrollment rate (%) of Peru in 2005 to that in 2011?
Give a very brief answer. 1.04. What is the ratio of the Enrollment rate (%) in European Union in 2006 to that in 2007?
Make the answer very short. 1. What is the ratio of the Enrollment rate (%) of Mexico in 2006 to that in 2007?
Make the answer very short. 1. What is the ratio of the Enrollment rate (%) in Spain in 2006 to that in 2007?
Offer a terse response. 1. What is the ratio of the Enrollment rate (%) of Peru in 2006 to that in 2008?
Give a very brief answer. 1.02. What is the ratio of the Enrollment rate (%) in Spain in 2006 to that in 2008?
Offer a terse response. 1. What is the ratio of the Enrollment rate (%) of Mexico in 2006 to that in 2009?
Offer a very short reply. 0.98. What is the ratio of the Enrollment rate (%) in Peru in 2006 to that in 2009?
Your response must be concise. 1.03. What is the ratio of the Enrollment rate (%) of Spain in 2006 to that in 2009?
Offer a terse response. 1. What is the ratio of the Enrollment rate (%) in Mexico in 2006 to that in 2010?
Your answer should be very brief. 0.97. What is the ratio of the Enrollment rate (%) of Peru in 2006 to that in 2010?
Ensure brevity in your answer.  1.02. What is the ratio of the Enrollment rate (%) in Spain in 2006 to that in 2010?
Ensure brevity in your answer.  1. What is the ratio of the Enrollment rate (%) of European Union in 2006 to that in 2011?
Offer a terse response. 1. What is the ratio of the Enrollment rate (%) in Mexico in 2006 to that in 2011?
Ensure brevity in your answer.  0.96. What is the ratio of the Enrollment rate (%) of Peru in 2006 to that in 2011?
Offer a terse response. 1.04. What is the ratio of the Enrollment rate (%) of Spain in 2006 to that in 2011?
Your response must be concise. 1. What is the ratio of the Enrollment rate (%) of European Union in 2007 to that in 2008?
Your answer should be compact. 1. What is the ratio of the Enrollment rate (%) in Peru in 2007 to that in 2008?
Give a very brief answer. 1.02. What is the ratio of the Enrollment rate (%) in Mexico in 2007 to that in 2009?
Offer a terse response. 0.99. What is the ratio of the Enrollment rate (%) in Peru in 2007 to that in 2009?
Offer a very short reply. 1.03. What is the ratio of the Enrollment rate (%) in Mexico in 2007 to that in 2010?
Your response must be concise. 0.97. What is the ratio of the Enrollment rate (%) of Peru in 2007 to that in 2010?
Keep it short and to the point. 1.02. What is the ratio of the Enrollment rate (%) of Spain in 2007 to that in 2010?
Give a very brief answer. 1. What is the ratio of the Enrollment rate (%) of European Union in 2007 to that in 2011?
Ensure brevity in your answer.  1. What is the ratio of the Enrollment rate (%) in Mexico in 2007 to that in 2011?
Provide a succinct answer. 0.97. What is the ratio of the Enrollment rate (%) of Peru in 2007 to that in 2011?
Offer a terse response. 1.04. What is the ratio of the Enrollment rate (%) of European Union in 2008 to that in 2009?
Your response must be concise. 1. What is the ratio of the Enrollment rate (%) of Mexico in 2008 to that in 2009?
Ensure brevity in your answer.  0.99. What is the ratio of the Enrollment rate (%) in Peru in 2008 to that in 2009?
Give a very brief answer. 1.01. What is the ratio of the Enrollment rate (%) in Spain in 2008 to that in 2009?
Make the answer very short. 1. What is the ratio of the Enrollment rate (%) of European Union in 2008 to that in 2010?
Make the answer very short. 1. What is the ratio of the Enrollment rate (%) of Mexico in 2008 to that in 2010?
Make the answer very short. 0.98. What is the ratio of the Enrollment rate (%) in Peru in 2008 to that in 2010?
Give a very brief answer. 1. What is the ratio of the Enrollment rate (%) of Spain in 2008 to that in 2010?
Provide a succinct answer. 1. What is the ratio of the Enrollment rate (%) in European Union in 2008 to that in 2011?
Make the answer very short. 1. What is the ratio of the Enrollment rate (%) of Mexico in 2008 to that in 2011?
Your answer should be compact. 0.97. What is the ratio of the Enrollment rate (%) in Peru in 2008 to that in 2011?
Your response must be concise. 1.02. What is the ratio of the Enrollment rate (%) of Spain in 2008 to that in 2011?
Ensure brevity in your answer.  1. What is the ratio of the Enrollment rate (%) of European Union in 2009 to that in 2010?
Ensure brevity in your answer.  1. What is the ratio of the Enrollment rate (%) in Mexico in 2009 to that in 2010?
Keep it short and to the point. 0.99. What is the ratio of the Enrollment rate (%) of Mexico in 2009 to that in 2011?
Give a very brief answer. 0.98. What is the ratio of the Enrollment rate (%) of Peru in 2009 to that in 2011?
Offer a very short reply. 1. What is the ratio of the Enrollment rate (%) of Peru in 2010 to that in 2011?
Provide a short and direct response. 1.01. What is the ratio of the Enrollment rate (%) of Spain in 2010 to that in 2011?
Make the answer very short. 1. What is the difference between the highest and the second highest Enrollment rate (%) of European Union?
Ensure brevity in your answer.  0.07. What is the difference between the highest and the second highest Enrollment rate (%) of Mexico?
Provide a succinct answer. 0.82. What is the difference between the highest and the second highest Enrollment rate (%) in Peru?
Provide a short and direct response. 0.03. What is the difference between the highest and the second highest Enrollment rate (%) of Spain?
Offer a very short reply. 0.07. What is the difference between the highest and the lowest Enrollment rate (%) in European Union?
Keep it short and to the point. 0.62. What is the difference between the highest and the lowest Enrollment rate (%) in Mexico?
Offer a terse response. 3.48. What is the difference between the highest and the lowest Enrollment rate (%) of Peru?
Your answer should be very brief. 3.48. What is the difference between the highest and the lowest Enrollment rate (%) of Spain?
Ensure brevity in your answer.  0.41. 